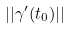Convert formula to latex. <formula><loc_0><loc_0><loc_500><loc_500>| | \gamma ^ { \prime } ( t _ { 0 } ) | |</formula> 